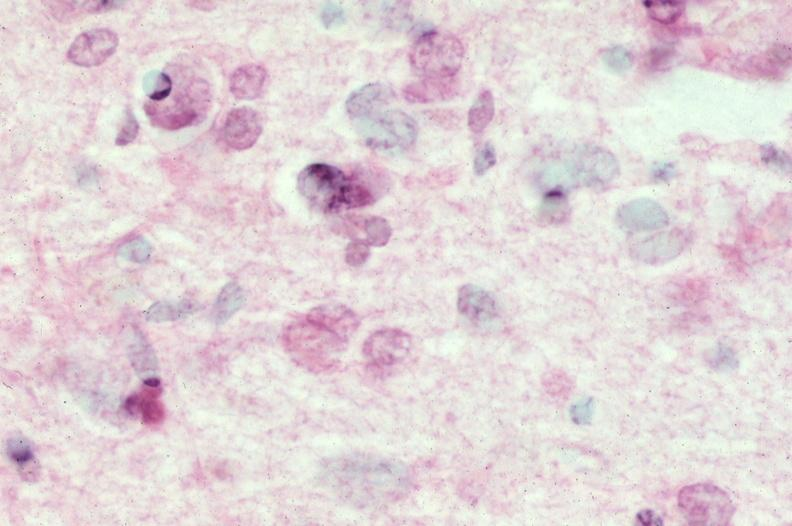does fixed tissue show brain, frontal lobe atrophy, pick 's disease?
Answer the question using a single word or phrase. No 